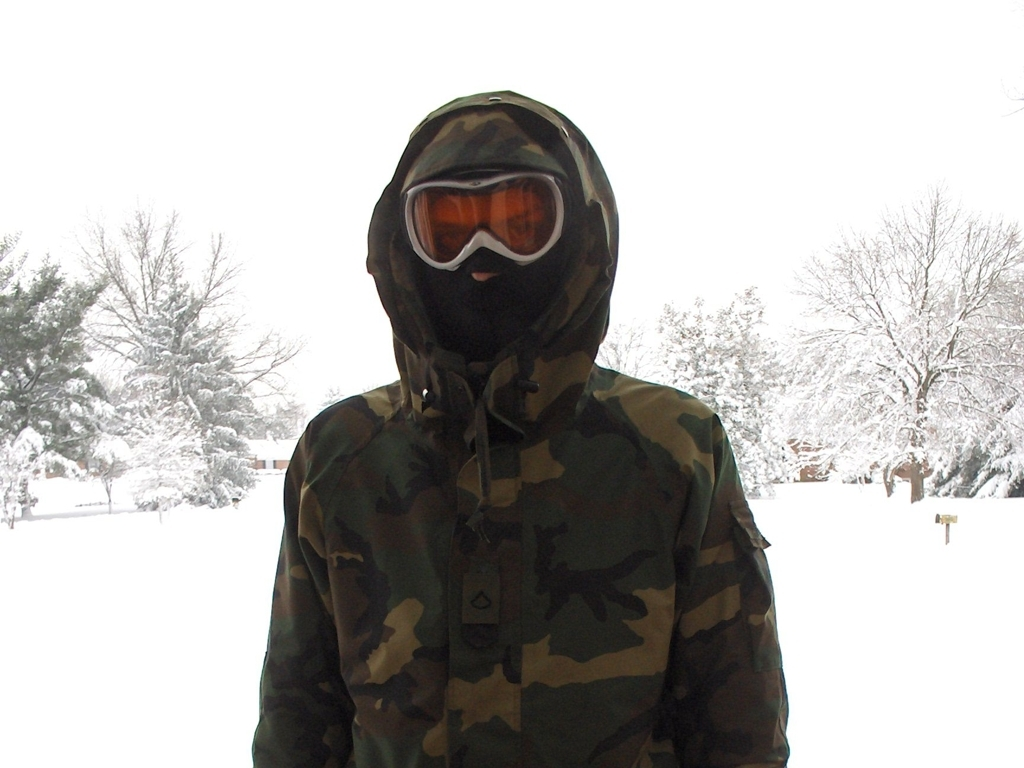Is there significant noise in the image? The image is relatively clear with minimal visible noise. The background shows a serene snow-covered landscape, and the main subject is a person dressed in a camouflage winter coat, suggesting a cold and possibly quiet setting. 